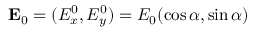<formula> <loc_0><loc_0><loc_500><loc_500>{ E } _ { 0 } = ( { E } _ { x } ^ { 0 } , { E } _ { y } ^ { 0 } ) = E _ { 0 } ( \cos \alpha , \sin \alpha )</formula> 